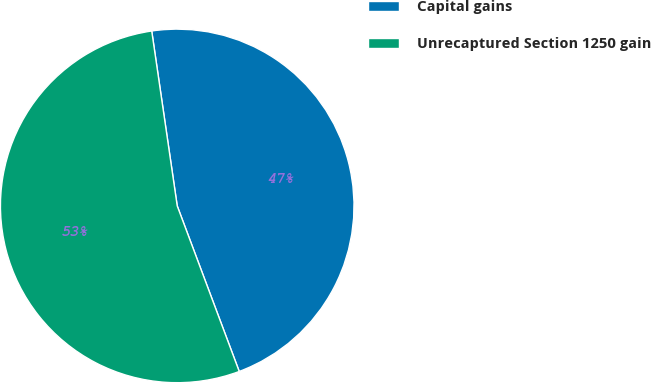Convert chart to OTSL. <chart><loc_0><loc_0><loc_500><loc_500><pie_chart><fcel>Capital gains<fcel>Unrecaptured Section 1250 gain<nl><fcel>46.6%<fcel>53.4%<nl></chart> 